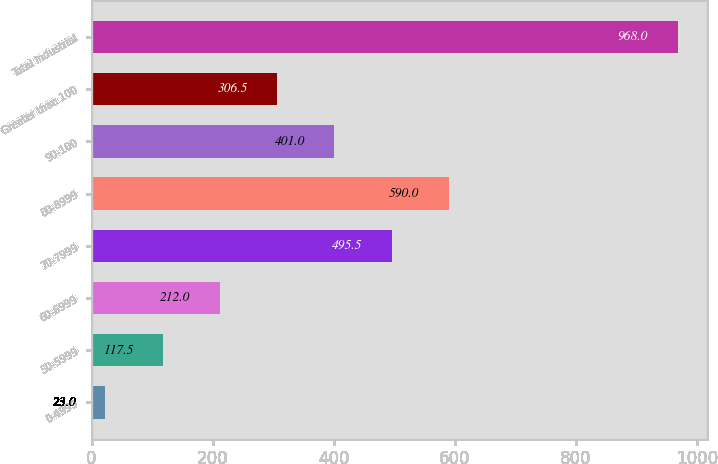Convert chart. <chart><loc_0><loc_0><loc_500><loc_500><bar_chart><fcel>0-4999<fcel>50-5999<fcel>60-6999<fcel>70-7999<fcel>80-8999<fcel>90-100<fcel>Greater than 100<fcel>Total Industrial<nl><fcel>23<fcel>117.5<fcel>212<fcel>495.5<fcel>590<fcel>401<fcel>306.5<fcel>968<nl></chart> 